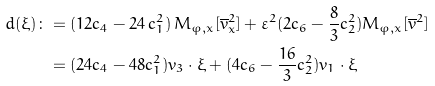Convert formula to latex. <formula><loc_0><loc_0><loc_500><loc_500>d ( \xi ) \colon & = ( 1 2 c _ { 4 } - 2 4 \, c _ { 1 } ^ { 2 } ) \, M _ { \varphi , x } [ \overline { v } _ { x } ^ { 2 } ] + \varepsilon ^ { 2 } ( 2 c _ { 6 } - \frac { 8 } { 3 } c _ { 2 } ^ { 2 } ) M _ { \varphi , x } [ \overline { v } ^ { 2 } ] \\ & = ( 2 4 c _ { 4 } - 4 8 c _ { 1 } ^ { 2 } ) v _ { 3 } \cdot \xi + ( 4 c _ { 6 } - \frac { 1 6 } { 3 } c _ { 2 } ^ { 2 } ) v _ { 1 } \cdot \xi</formula> 